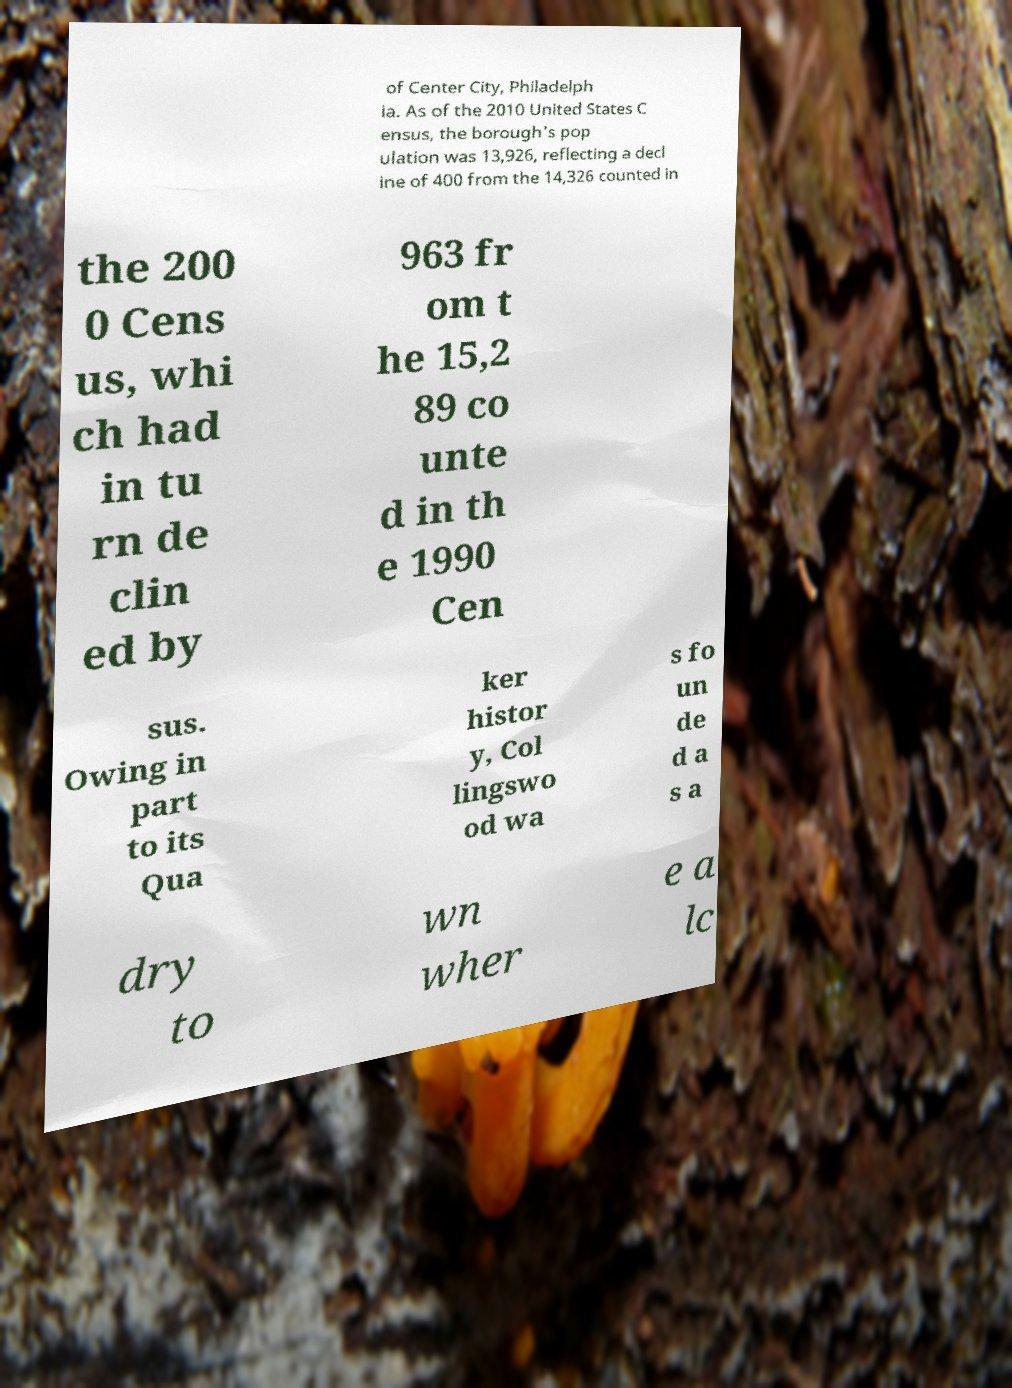I need the written content from this picture converted into text. Can you do that? of Center City, Philadelph ia. As of the 2010 United States C ensus, the borough's pop ulation was 13,926, reflecting a decl ine of 400 from the 14,326 counted in the 200 0 Cens us, whi ch had in tu rn de clin ed by 963 fr om t he 15,2 89 co unte d in th e 1990 Cen sus. Owing in part to its Qua ker histor y, Col lingswo od wa s fo un de d a s a dry to wn wher e a lc 